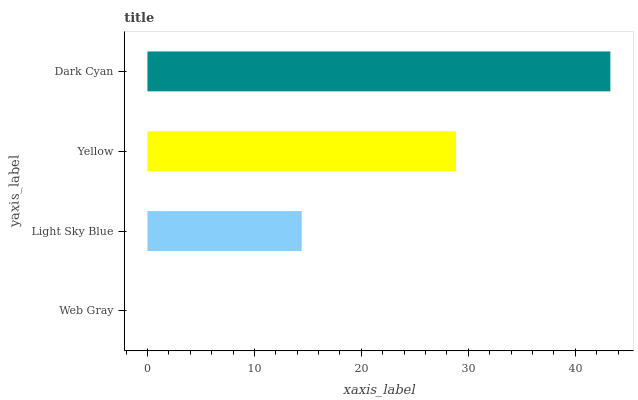Is Web Gray the minimum?
Answer yes or no. Yes. Is Dark Cyan the maximum?
Answer yes or no. Yes. Is Light Sky Blue the minimum?
Answer yes or no. No. Is Light Sky Blue the maximum?
Answer yes or no. No. Is Light Sky Blue greater than Web Gray?
Answer yes or no. Yes. Is Web Gray less than Light Sky Blue?
Answer yes or no. Yes. Is Web Gray greater than Light Sky Blue?
Answer yes or no. No. Is Light Sky Blue less than Web Gray?
Answer yes or no. No. Is Yellow the high median?
Answer yes or no. Yes. Is Light Sky Blue the low median?
Answer yes or no. Yes. Is Web Gray the high median?
Answer yes or no. No. Is Yellow the low median?
Answer yes or no. No. 